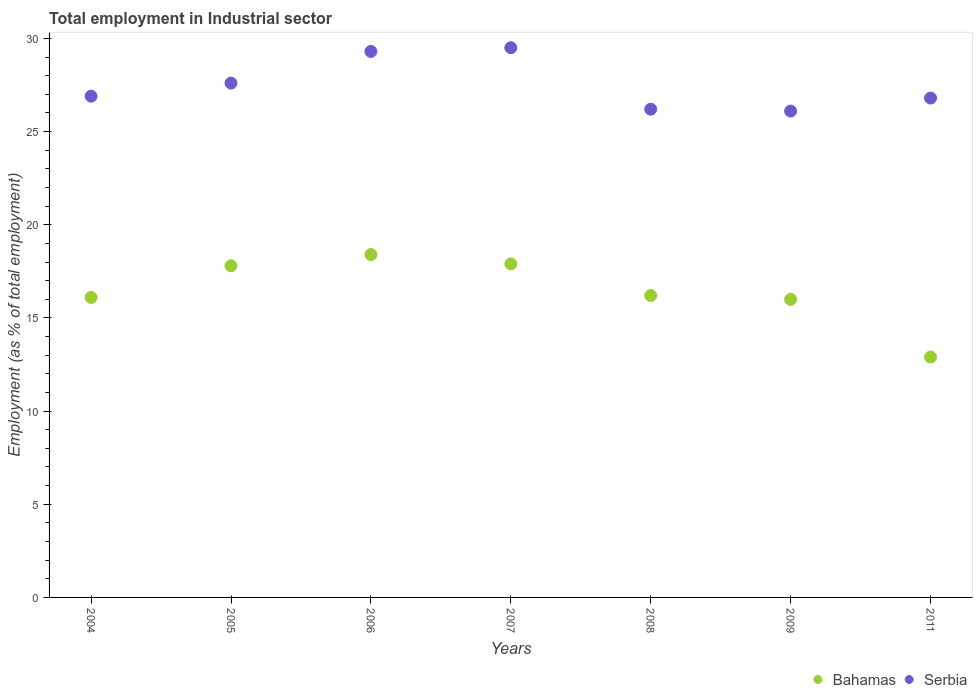How many different coloured dotlines are there?
Ensure brevity in your answer.  2. What is the employment in industrial sector in Bahamas in 2007?
Your answer should be compact. 17.9. Across all years, what is the maximum employment in industrial sector in Bahamas?
Provide a succinct answer. 18.4. Across all years, what is the minimum employment in industrial sector in Serbia?
Give a very brief answer. 26.1. In which year was the employment in industrial sector in Bahamas minimum?
Offer a very short reply. 2011. What is the total employment in industrial sector in Serbia in the graph?
Offer a terse response. 192.4. What is the difference between the employment in industrial sector in Bahamas in 2007 and that in 2011?
Provide a succinct answer. 5. What is the difference between the employment in industrial sector in Serbia in 2004 and the employment in industrial sector in Bahamas in 2008?
Ensure brevity in your answer.  10.7. What is the average employment in industrial sector in Bahamas per year?
Give a very brief answer. 16.47. In the year 2007, what is the difference between the employment in industrial sector in Serbia and employment in industrial sector in Bahamas?
Offer a very short reply. 11.6. In how many years, is the employment in industrial sector in Serbia greater than 24 %?
Keep it short and to the point. 7. What is the ratio of the employment in industrial sector in Bahamas in 2005 to that in 2008?
Provide a short and direct response. 1.1. Is the difference between the employment in industrial sector in Serbia in 2005 and 2007 greater than the difference between the employment in industrial sector in Bahamas in 2005 and 2007?
Provide a succinct answer. No. What is the difference between the highest and the second highest employment in industrial sector in Bahamas?
Your answer should be compact. 0.5. What is the difference between the highest and the lowest employment in industrial sector in Bahamas?
Provide a short and direct response. 5.5. In how many years, is the employment in industrial sector in Bahamas greater than the average employment in industrial sector in Bahamas taken over all years?
Offer a very short reply. 3. Does the employment in industrial sector in Serbia monotonically increase over the years?
Your response must be concise. No. Is the employment in industrial sector in Bahamas strictly greater than the employment in industrial sector in Serbia over the years?
Ensure brevity in your answer.  No. Are the values on the major ticks of Y-axis written in scientific E-notation?
Ensure brevity in your answer.  No. Where does the legend appear in the graph?
Ensure brevity in your answer.  Bottom right. How many legend labels are there?
Your answer should be very brief. 2. What is the title of the graph?
Make the answer very short. Total employment in Industrial sector. What is the label or title of the Y-axis?
Keep it short and to the point. Employment (as % of total employment). What is the Employment (as % of total employment) in Bahamas in 2004?
Give a very brief answer. 16.1. What is the Employment (as % of total employment) of Serbia in 2004?
Provide a short and direct response. 26.9. What is the Employment (as % of total employment) in Bahamas in 2005?
Ensure brevity in your answer.  17.8. What is the Employment (as % of total employment) in Serbia in 2005?
Provide a short and direct response. 27.6. What is the Employment (as % of total employment) in Bahamas in 2006?
Ensure brevity in your answer.  18.4. What is the Employment (as % of total employment) in Serbia in 2006?
Provide a succinct answer. 29.3. What is the Employment (as % of total employment) in Bahamas in 2007?
Your response must be concise. 17.9. What is the Employment (as % of total employment) in Serbia in 2007?
Give a very brief answer. 29.5. What is the Employment (as % of total employment) of Bahamas in 2008?
Offer a very short reply. 16.2. What is the Employment (as % of total employment) in Serbia in 2008?
Your response must be concise. 26.2. What is the Employment (as % of total employment) of Serbia in 2009?
Provide a succinct answer. 26.1. What is the Employment (as % of total employment) of Bahamas in 2011?
Offer a very short reply. 12.9. What is the Employment (as % of total employment) in Serbia in 2011?
Give a very brief answer. 26.8. Across all years, what is the maximum Employment (as % of total employment) of Bahamas?
Your answer should be compact. 18.4. Across all years, what is the maximum Employment (as % of total employment) in Serbia?
Give a very brief answer. 29.5. Across all years, what is the minimum Employment (as % of total employment) of Bahamas?
Keep it short and to the point. 12.9. Across all years, what is the minimum Employment (as % of total employment) in Serbia?
Offer a terse response. 26.1. What is the total Employment (as % of total employment) of Bahamas in the graph?
Offer a very short reply. 115.3. What is the total Employment (as % of total employment) of Serbia in the graph?
Your response must be concise. 192.4. What is the difference between the Employment (as % of total employment) of Bahamas in 2004 and that in 2005?
Your answer should be very brief. -1.7. What is the difference between the Employment (as % of total employment) in Serbia in 2004 and that in 2005?
Give a very brief answer. -0.7. What is the difference between the Employment (as % of total employment) in Bahamas in 2004 and that in 2006?
Give a very brief answer. -2.3. What is the difference between the Employment (as % of total employment) in Bahamas in 2004 and that in 2007?
Make the answer very short. -1.8. What is the difference between the Employment (as % of total employment) in Serbia in 2004 and that in 2008?
Your response must be concise. 0.7. What is the difference between the Employment (as % of total employment) of Bahamas in 2004 and that in 2009?
Your response must be concise. 0.1. What is the difference between the Employment (as % of total employment) of Bahamas in 2004 and that in 2011?
Your answer should be very brief. 3.2. What is the difference between the Employment (as % of total employment) in Bahamas in 2005 and that in 2006?
Keep it short and to the point. -0.6. What is the difference between the Employment (as % of total employment) of Serbia in 2005 and that in 2006?
Ensure brevity in your answer.  -1.7. What is the difference between the Employment (as % of total employment) of Bahamas in 2005 and that in 2007?
Ensure brevity in your answer.  -0.1. What is the difference between the Employment (as % of total employment) in Serbia in 2005 and that in 2007?
Give a very brief answer. -1.9. What is the difference between the Employment (as % of total employment) of Serbia in 2005 and that in 2008?
Your answer should be very brief. 1.4. What is the difference between the Employment (as % of total employment) in Bahamas in 2005 and that in 2011?
Offer a very short reply. 4.9. What is the difference between the Employment (as % of total employment) of Bahamas in 2006 and that in 2008?
Keep it short and to the point. 2.2. What is the difference between the Employment (as % of total employment) of Serbia in 2006 and that in 2008?
Your answer should be compact. 3.1. What is the difference between the Employment (as % of total employment) in Serbia in 2006 and that in 2011?
Offer a terse response. 2.5. What is the difference between the Employment (as % of total employment) of Bahamas in 2007 and that in 2008?
Offer a very short reply. 1.7. What is the difference between the Employment (as % of total employment) of Serbia in 2007 and that in 2008?
Ensure brevity in your answer.  3.3. What is the difference between the Employment (as % of total employment) of Bahamas in 2007 and that in 2009?
Make the answer very short. 1.9. What is the difference between the Employment (as % of total employment) in Serbia in 2007 and that in 2009?
Your answer should be compact. 3.4. What is the difference between the Employment (as % of total employment) of Serbia in 2008 and that in 2009?
Ensure brevity in your answer.  0.1. What is the difference between the Employment (as % of total employment) of Bahamas in 2008 and that in 2011?
Your response must be concise. 3.3. What is the difference between the Employment (as % of total employment) of Serbia in 2009 and that in 2011?
Keep it short and to the point. -0.7. What is the difference between the Employment (as % of total employment) of Bahamas in 2004 and the Employment (as % of total employment) of Serbia in 2005?
Keep it short and to the point. -11.5. What is the difference between the Employment (as % of total employment) of Bahamas in 2004 and the Employment (as % of total employment) of Serbia in 2007?
Keep it short and to the point. -13.4. What is the difference between the Employment (as % of total employment) of Bahamas in 2004 and the Employment (as % of total employment) of Serbia in 2011?
Provide a succinct answer. -10.7. What is the difference between the Employment (as % of total employment) in Bahamas in 2005 and the Employment (as % of total employment) in Serbia in 2006?
Offer a terse response. -11.5. What is the difference between the Employment (as % of total employment) in Bahamas in 2005 and the Employment (as % of total employment) in Serbia in 2009?
Provide a succinct answer. -8.3. What is the difference between the Employment (as % of total employment) in Bahamas in 2006 and the Employment (as % of total employment) in Serbia in 2007?
Offer a terse response. -11.1. What is the difference between the Employment (as % of total employment) in Bahamas in 2006 and the Employment (as % of total employment) in Serbia in 2011?
Ensure brevity in your answer.  -8.4. What is the difference between the Employment (as % of total employment) of Bahamas in 2007 and the Employment (as % of total employment) of Serbia in 2008?
Offer a very short reply. -8.3. What is the difference between the Employment (as % of total employment) of Bahamas in 2007 and the Employment (as % of total employment) of Serbia in 2009?
Your response must be concise. -8.2. What is the difference between the Employment (as % of total employment) of Bahamas in 2008 and the Employment (as % of total employment) of Serbia in 2011?
Keep it short and to the point. -10.6. What is the difference between the Employment (as % of total employment) of Bahamas in 2009 and the Employment (as % of total employment) of Serbia in 2011?
Keep it short and to the point. -10.8. What is the average Employment (as % of total employment) of Bahamas per year?
Offer a terse response. 16.47. What is the average Employment (as % of total employment) of Serbia per year?
Provide a succinct answer. 27.49. In the year 2004, what is the difference between the Employment (as % of total employment) of Bahamas and Employment (as % of total employment) of Serbia?
Your answer should be very brief. -10.8. In the year 2005, what is the difference between the Employment (as % of total employment) of Bahamas and Employment (as % of total employment) of Serbia?
Offer a terse response. -9.8. In the year 2008, what is the difference between the Employment (as % of total employment) of Bahamas and Employment (as % of total employment) of Serbia?
Keep it short and to the point. -10. What is the ratio of the Employment (as % of total employment) in Bahamas in 2004 to that in 2005?
Offer a terse response. 0.9. What is the ratio of the Employment (as % of total employment) of Serbia in 2004 to that in 2005?
Provide a succinct answer. 0.97. What is the ratio of the Employment (as % of total employment) of Serbia in 2004 to that in 2006?
Provide a succinct answer. 0.92. What is the ratio of the Employment (as % of total employment) of Bahamas in 2004 to that in 2007?
Provide a short and direct response. 0.9. What is the ratio of the Employment (as % of total employment) of Serbia in 2004 to that in 2007?
Your response must be concise. 0.91. What is the ratio of the Employment (as % of total employment) in Bahamas in 2004 to that in 2008?
Make the answer very short. 0.99. What is the ratio of the Employment (as % of total employment) of Serbia in 2004 to that in 2008?
Provide a short and direct response. 1.03. What is the ratio of the Employment (as % of total employment) of Serbia in 2004 to that in 2009?
Provide a succinct answer. 1.03. What is the ratio of the Employment (as % of total employment) of Bahamas in 2004 to that in 2011?
Provide a succinct answer. 1.25. What is the ratio of the Employment (as % of total employment) in Bahamas in 2005 to that in 2006?
Your answer should be compact. 0.97. What is the ratio of the Employment (as % of total employment) in Serbia in 2005 to that in 2006?
Provide a succinct answer. 0.94. What is the ratio of the Employment (as % of total employment) of Serbia in 2005 to that in 2007?
Provide a succinct answer. 0.94. What is the ratio of the Employment (as % of total employment) of Bahamas in 2005 to that in 2008?
Your answer should be very brief. 1.1. What is the ratio of the Employment (as % of total employment) in Serbia in 2005 to that in 2008?
Your answer should be compact. 1.05. What is the ratio of the Employment (as % of total employment) in Bahamas in 2005 to that in 2009?
Offer a terse response. 1.11. What is the ratio of the Employment (as % of total employment) in Serbia in 2005 to that in 2009?
Your answer should be very brief. 1.06. What is the ratio of the Employment (as % of total employment) in Bahamas in 2005 to that in 2011?
Offer a terse response. 1.38. What is the ratio of the Employment (as % of total employment) in Serbia in 2005 to that in 2011?
Provide a short and direct response. 1.03. What is the ratio of the Employment (as % of total employment) of Bahamas in 2006 to that in 2007?
Give a very brief answer. 1.03. What is the ratio of the Employment (as % of total employment) of Bahamas in 2006 to that in 2008?
Offer a terse response. 1.14. What is the ratio of the Employment (as % of total employment) of Serbia in 2006 to that in 2008?
Ensure brevity in your answer.  1.12. What is the ratio of the Employment (as % of total employment) in Bahamas in 2006 to that in 2009?
Offer a very short reply. 1.15. What is the ratio of the Employment (as % of total employment) in Serbia in 2006 to that in 2009?
Provide a succinct answer. 1.12. What is the ratio of the Employment (as % of total employment) of Bahamas in 2006 to that in 2011?
Provide a succinct answer. 1.43. What is the ratio of the Employment (as % of total employment) of Serbia in 2006 to that in 2011?
Your answer should be compact. 1.09. What is the ratio of the Employment (as % of total employment) in Bahamas in 2007 to that in 2008?
Ensure brevity in your answer.  1.1. What is the ratio of the Employment (as % of total employment) of Serbia in 2007 to that in 2008?
Offer a terse response. 1.13. What is the ratio of the Employment (as % of total employment) of Bahamas in 2007 to that in 2009?
Your answer should be compact. 1.12. What is the ratio of the Employment (as % of total employment) in Serbia in 2007 to that in 2009?
Your response must be concise. 1.13. What is the ratio of the Employment (as % of total employment) of Bahamas in 2007 to that in 2011?
Keep it short and to the point. 1.39. What is the ratio of the Employment (as % of total employment) in Serbia in 2007 to that in 2011?
Keep it short and to the point. 1.1. What is the ratio of the Employment (as % of total employment) of Bahamas in 2008 to that in 2009?
Your response must be concise. 1.01. What is the ratio of the Employment (as % of total employment) of Bahamas in 2008 to that in 2011?
Give a very brief answer. 1.26. What is the ratio of the Employment (as % of total employment) in Serbia in 2008 to that in 2011?
Offer a very short reply. 0.98. What is the ratio of the Employment (as % of total employment) in Bahamas in 2009 to that in 2011?
Your response must be concise. 1.24. What is the ratio of the Employment (as % of total employment) in Serbia in 2009 to that in 2011?
Provide a succinct answer. 0.97. What is the difference between the highest and the second highest Employment (as % of total employment) of Serbia?
Keep it short and to the point. 0.2. What is the difference between the highest and the lowest Employment (as % of total employment) of Bahamas?
Offer a terse response. 5.5. 